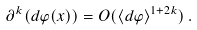<formula> <loc_0><loc_0><loc_500><loc_500>\partial ^ { k } ( d \varphi ( x ) ) = O ( \langle d \varphi \rangle ^ { 1 + 2 k } ) \, .</formula> 